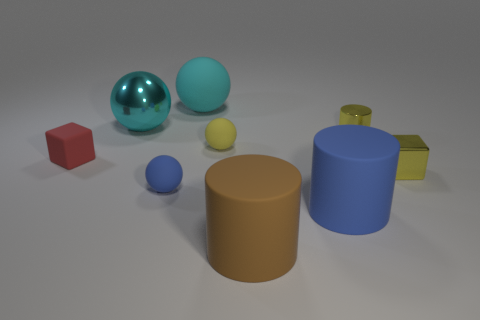There is a object that is in front of the red thing and behind the blue sphere; what is its size?
Give a very brief answer. Small. The rubber thing that is the same color as the large metal object is what shape?
Provide a succinct answer. Sphere. The small metal cylinder is what color?
Your response must be concise. Yellow. What size is the shiny thing that is in front of the tiny cylinder?
Ensure brevity in your answer.  Small. There is a small cube that is on the right side of the tiny yellow thing that is to the left of the big blue matte object; how many metal cubes are behind it?
Provide a succinct answer. 0. What color is the small cube left of the thing that is behind the large shiny sphere?
Your answer should be very brief. Red. Is there a rubber cylinder of the same size as the brown thing?
Keep it short and to the point. Yes. What is the material of the cube right of the tiny thing that is behind the small sphere to the right of the small blue rubber object?
Keep it short and to the point. Metal. How many things are left of the large rubber thing that is behind the small red object?
Keep it short and to the point. 3. There is a block that is left of the yellow metallic cube; is it the same size as the cyan rubber sphere?
Ensure brevity in your answer.  No. 